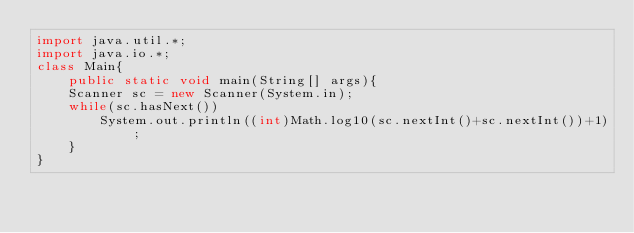<code> <loc_0><loc_0><loc_500><loc_500><_Java_>import java.util.*;
import java.io.*;
class Main{
    public static void main(String[] args){
	Scanner sc = new Scanner(System.in);
	while(sc.hasNext())
	    System.out.println((int)Math.log10(sc.nextInt()+sc.nextInt())+1);
    }
}</code> 